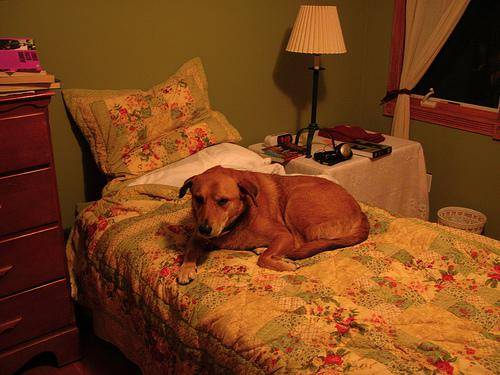Question: what animal is in the photo?
Choices:
A. A cat.
B. A bunny.
C. A dog.
D. A horse.
Answer with the letter. Answer: C Question: how many drawers are in the chest?
Choices:
A. Three.
B. Four.
C. Two.
D. Five.
Answer with the letter. Answer: D Question: where is the waste basket?
Choices:
A. In the kitchen.
B. By the bathroom.
C. By the wall.
D. Under the window.
Answer with the letter. Answer: D Question: how is the window opened?
Choices:
A. By using a crank.
B. By pulling up the ledge.
C. By using the lever.
D. By sliding the glass over.
Answer with the letter. Answer: A 